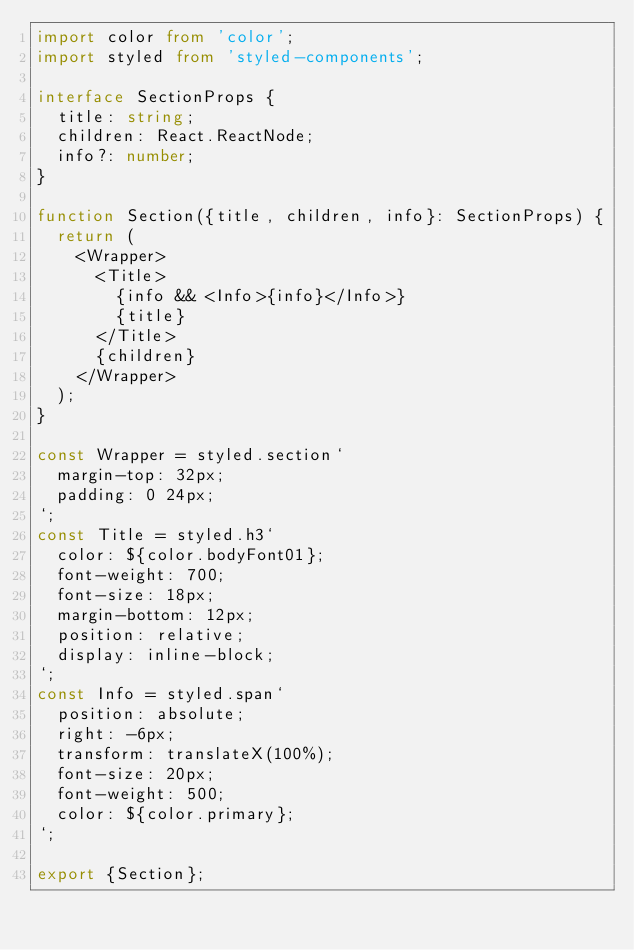<code> <loc_0><loc_0><loc_500><loc_500><_TypeScript_>import color from 'color';
import styled from 'styled-components';

interface SectionProps {
  title: string;
  children: React.ReactNode;
  info?: number;
}

function Section({title, children, info}: SectionProps) {
  return (
    <Wrapper>
      <Title>
        {info && <Info>{info}</Info>}
        {title}
      </Title>
      {children}
    </Wrapper>
  );
}

const Wrapper = styled.section`
  margin-top: 32px;
  padding: 0 24px;
`;
const Title = styled.h3`
  color: ${color.bodyFont01};
  font-weight: 700;
  font-size: 18px;
  margin-bottom: 12px;
  position: relative;
  display: inline-block;
`;
const Info = styled.span`
  position: absolute;
  right: -6px;
  transform: translateX(100%);
  font-size: 20px;
  font-weight: 500;
  color: ${color.primary};
`;

export {Section};
</code> 